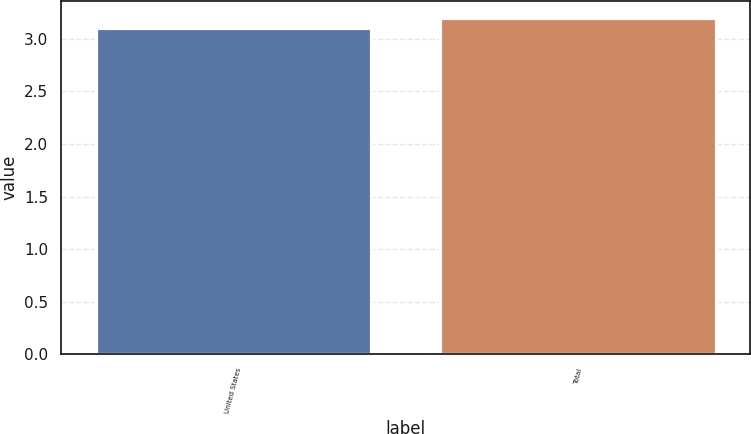<chart> <loc_0><loc_0><loc_500><loc_500><bar_chart><fcel>United States<fcel>Total<nl><fcel>3.1<fcel>3.2<nl></chart> 